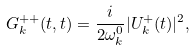Convert formula to latex. <formula><loc_0><loc_0><loc_500><loc_500>G _ { k } ^ { + + } ( t , t ) = \frac { i } { 2 \omega ^ { 0 } _ { k } } | U ^ { + } _ { k } ( t ) | ^ { 2 } ,</formula> 